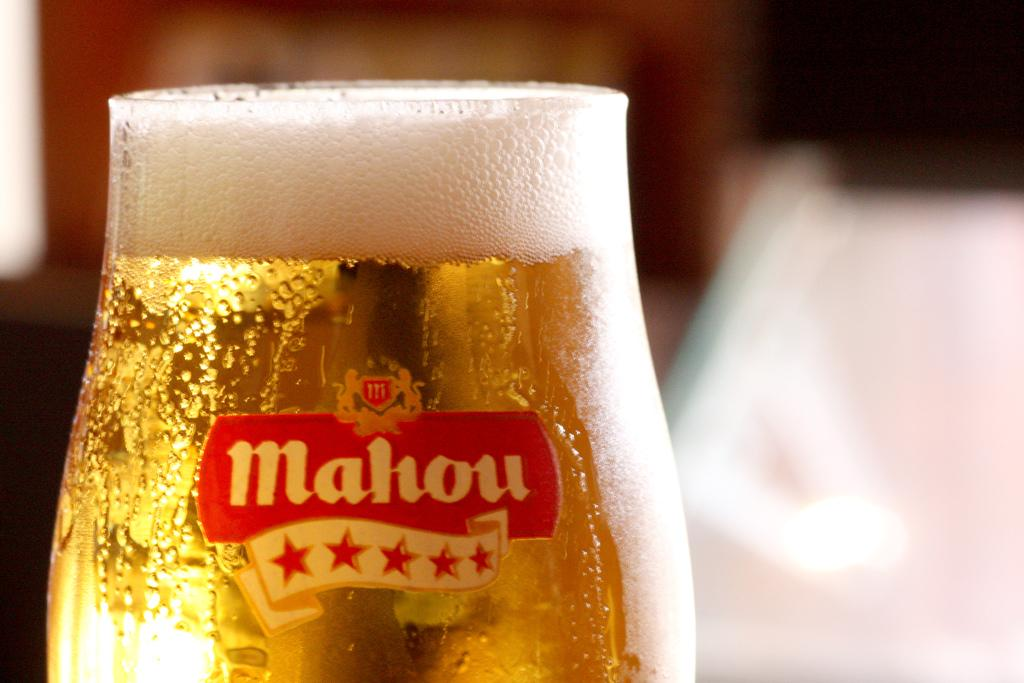<image>
Provide a brief description of the given image. A frothy glass of Mahou beer is seen close up. 